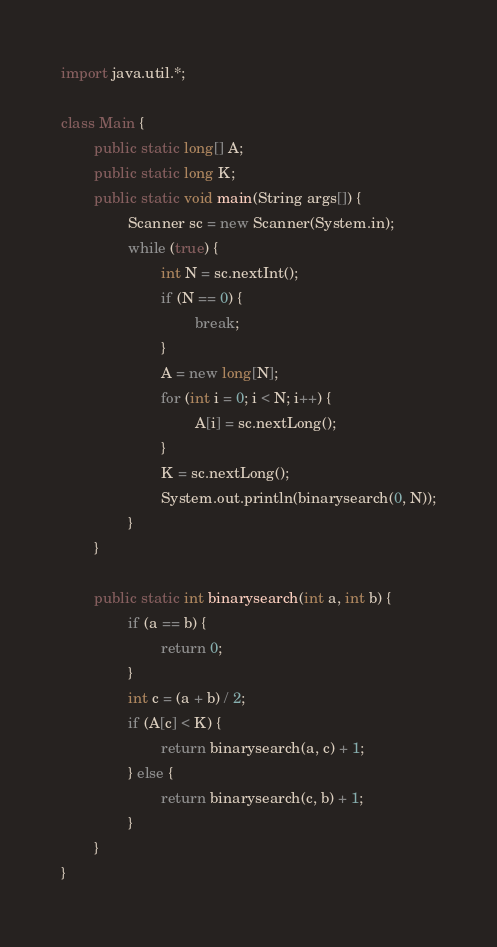Convert code to text. <code><loc_0><loc_0><loc_500><loc_500><_Java_>import java.util.*;

class Main {
        public static long[] A;
        public static long K;
        public static void main(String args[]) {
                Scanner sc = new Scanner(System.in);
                while (true) {
                        int N = sc.nextInt();
                        if (N == 0) {
                                break;
                        }
                        A = new long[N];
                        for (int i = 0; i < N; i++) {
                                A[i] = sc.nextLong();
                        }
                        K = sc.nextLong();
                        System.out.println(binarysearch(0, N));
                }
        }

        public static int binarysearch(int a, int b) {
                if (a == b) {
                        return 0;
                }
                int c = (a + b) / 2;
                if (A[c] < K) {
                        return binarysearch(a, c) + 1;
                } else {
                        return binarysearch(c, b) + 1;
                }
        }
}</code> 